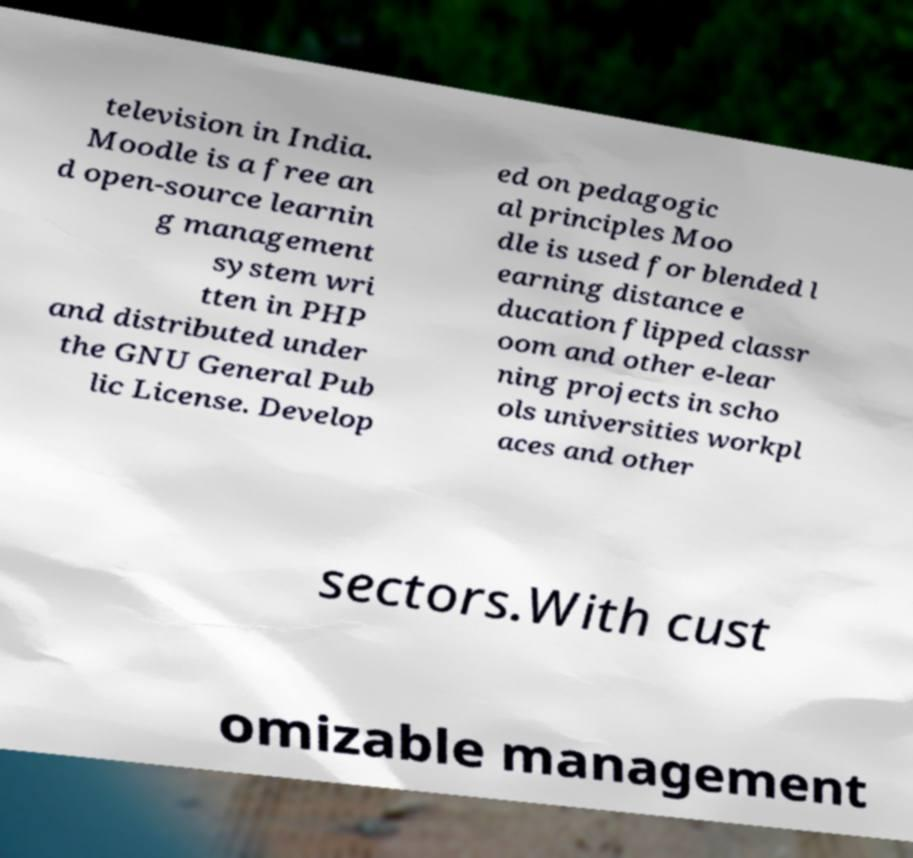I need the written content from this picture converted into text. Can you do that? television in India. Moodle is a free an d open-source learnin g management system wri tten in PHP and distributed under the GNU General Pub lic License. Develop ed on pedagogic al principles Moo dle is used for blended l earning distance e ducation flipped classr oom and other e-lear ning projects in scho ols universities workpl aces and other sectors.With cust omizable management 